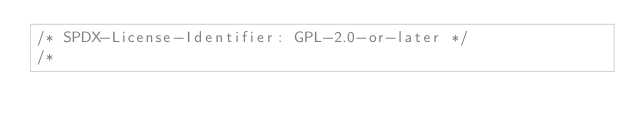<code> <loc_0><loc_0><loc_500><loc_500><_C_>/* SPDX-License-Identifier: GPL-2.0-or-later */
/*</code> 